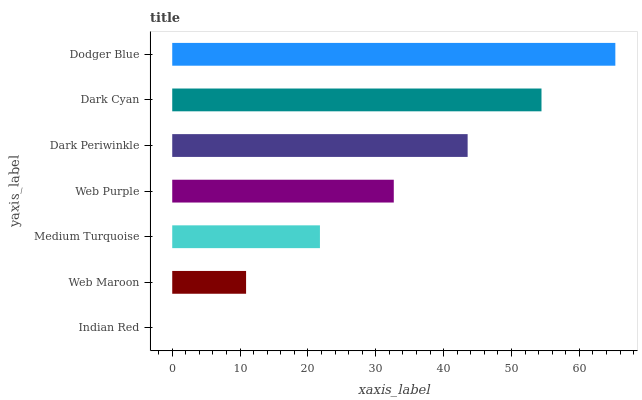Is Indian Red the minimum?
Answer yes or no. Yes. Is Dodger Blue the maximum?
Answer yes or no. Yes. Is Web Maroon the minimum?
Answer yes or no. No. Is Web Maroon the maximum?
Answer yes or no. No. Is Web Maroon greater than Indian Red?
Answer yes or no. Yes. Is Indian Red less than Web Maroon?
Answer yes or no. Yes. Is Indian Red greater than Web Maroon?
Answer yes or no. No. Is Web Maroon less than Indian Red?
Answer yes or no. No. Is Web Purple the high median?
Answer yes or no. Yes. Is Web Purple the low median?
Answer yes or no. Yes. Is Medium Turquoise the high median?
Answer yes or no. No. Is Web Maroon the low median?
Answer yes or no. No. 